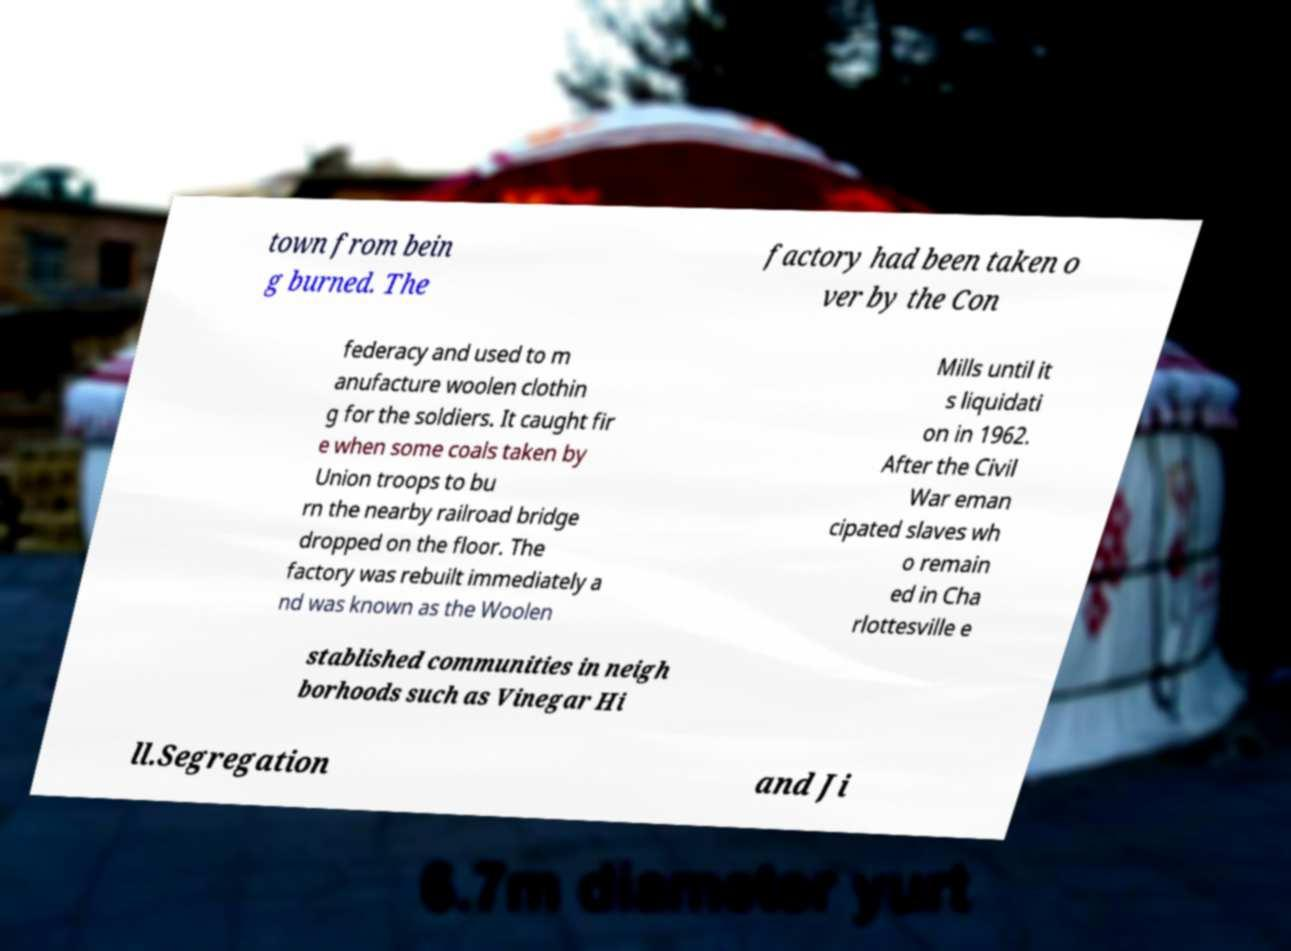Could you extract and type out the text from this image? town from bein g burned. The factory had been taken o ver by the Con federacy and used to m anufacture woolen clothin g for the soldiers. It caught fir e when some coals taken by Union troops to bu rn the nearby railroad bridge dropped on the floor. The factory was rebuilt immediately a nd was known as the Woolen Mills until it s liquidati on in 1962. After the Civil War eman cipated slaves wh o remain ed in Cha rlottesville e stablished communities in neigh borhoods such as Vinegar Hi ll.Segregation and Ji 